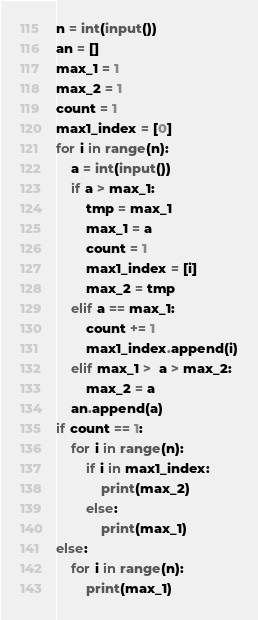Convert code to text. <code><loc_0><loc_0><loc_500><loc_500><_Python_>n = int(input())
an = []
max_1 = 1
max_2 = 1
count = 1
max1_index = [0]
for i in range(n):
    a = int(input())
    if a > max_1:
        tmp = max_1
        max_1 = a
        count = 1
        max1_index = [i]
        max_2 = tmp
    elif a == max_1:
        count += 1
        max1_index.append(i)
    elif max_1 >  a > max_2:
        max_2 = a
    an.append(a)
if count == 1:
    for i in range(n):
        if i in max1_index:
            print(max_2)
        else:
            print(max_1)
else:
    for i in range(n):
        print(max_1)</code> 